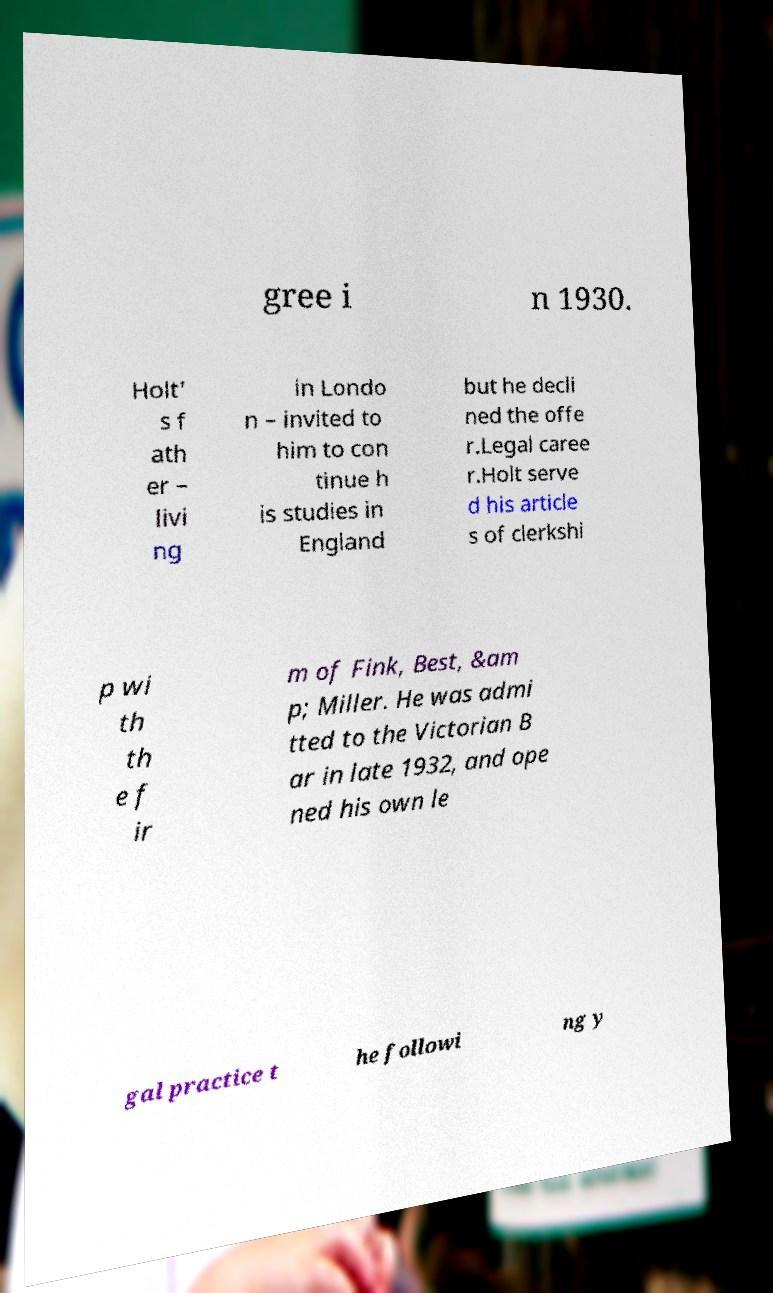Please read and relay the text visible in this image. What does it say? gree i n 1930. Holt' s f ath er – livi ng in Londo n – invited to him to con tinue h is studies in England but he decli ned the offe r.Legal caree r.Holt serve d his article s of clerkshi p wi th th e f ir m of Fink, Best, &am p; Miller. He was admi tted to the Victorian B ar in late 1932, and ope ned his own le gal practice t he followi ng y 